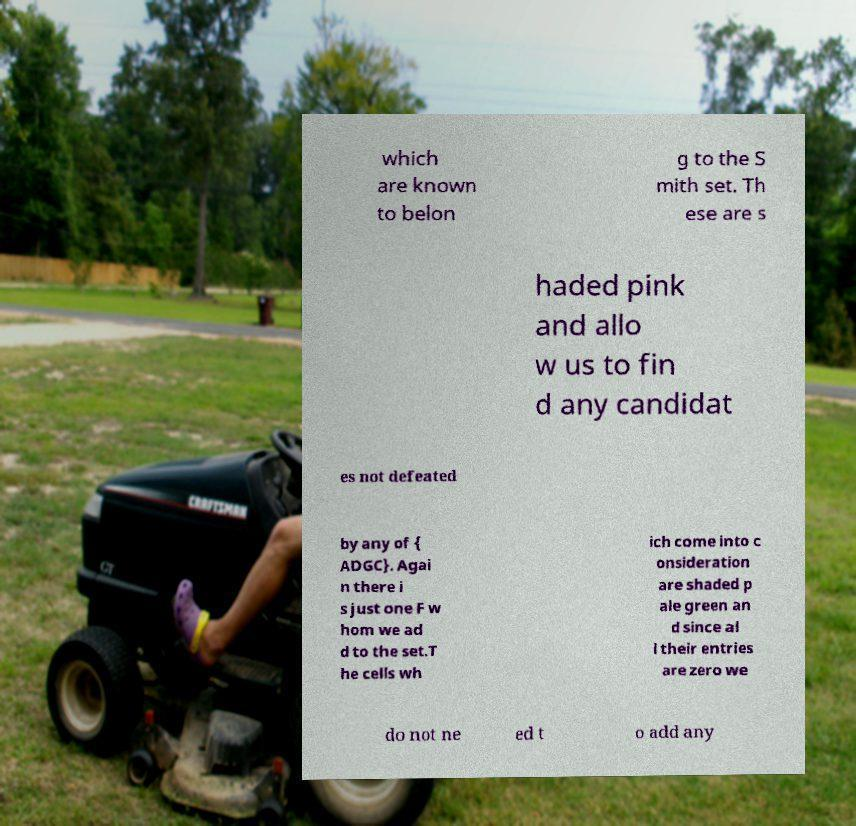Please read and relay the text visible in this image. What does it say? which are known to belon g to the S mith set. Th ese are s haded pink and allo w us to fin d any candidat es not defeated by any of { ADGC}. Agai n there i s just one F w hom we ad d to the set.T he cells wh ich come into c onsideration are shaded p ale green an d since al l their entries are zero we do not ne ed t o add any 